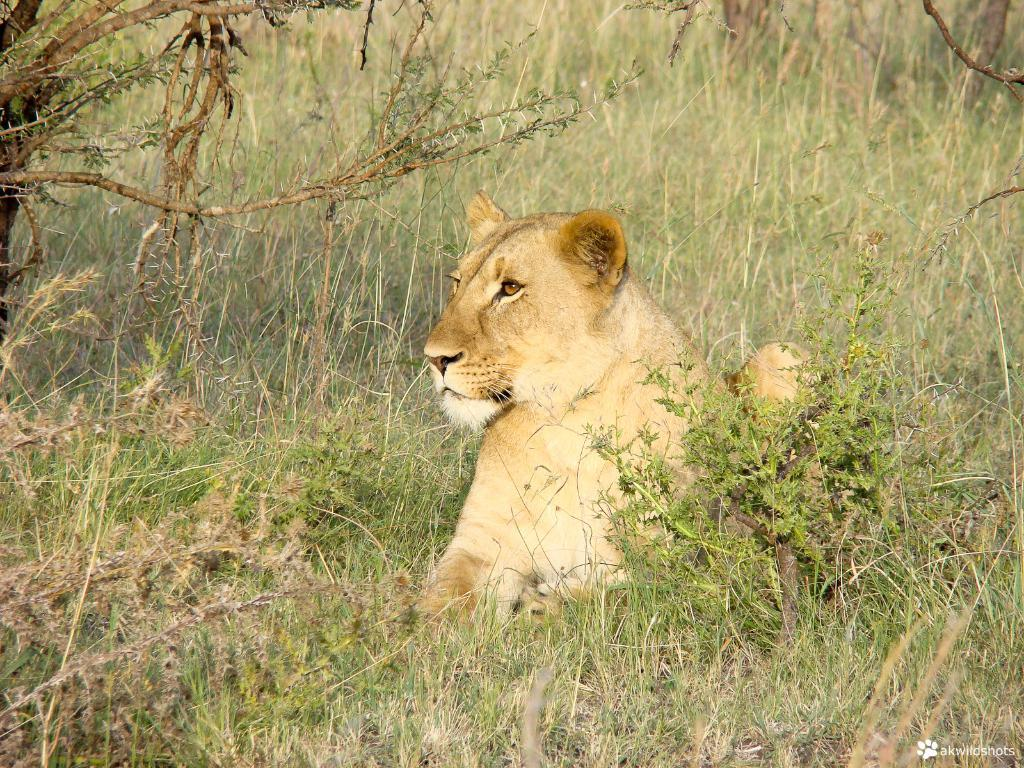What type of animal can be seen in the image? There is an animal in the image, but its specific type cannot be determined from the provided facts. What colors are present on the animal? The animal has brown and white colors. Where is the animal located in the image? The animal is on the grass. What can be seen in the background of the image? There are plants in the background of the image. What type of machine is being used by the animal in the image? There is no machine present in the image, and the animal is not using any machine. Can you tell me how many basketballs are visible in the image? There are no basketballs present in the image. 